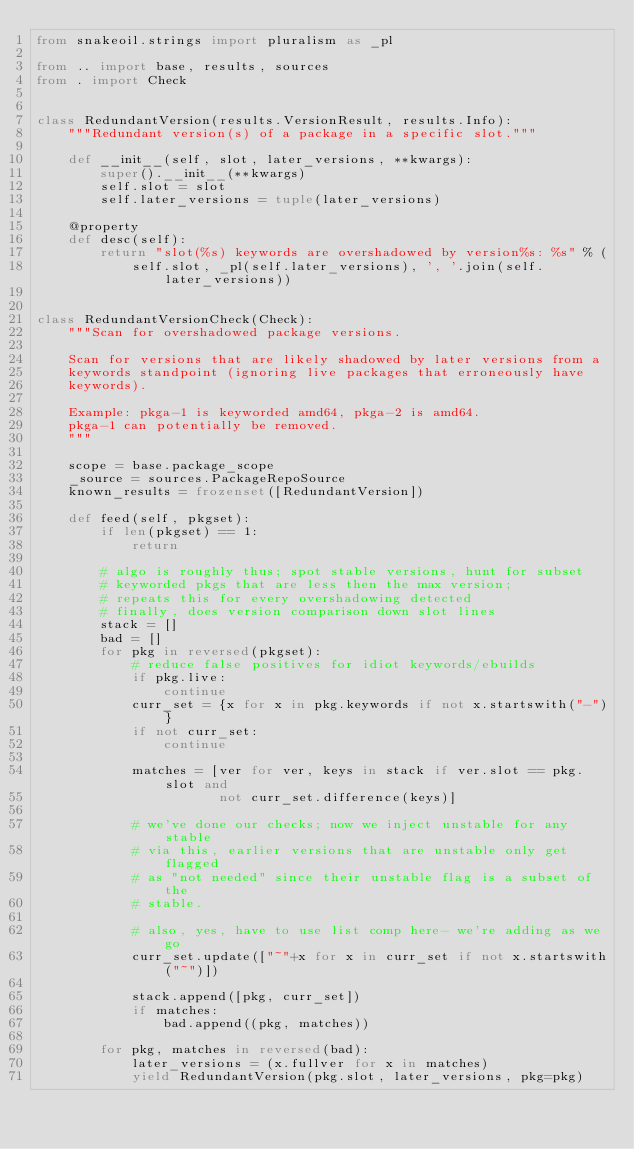<code> <loc_0><loc_0><loc_500><loc_500><_Python_>from snakeoil.strings import pluralism as _pl

from .. import base, results, sources
from . import Check


class RedundantVersion(results.VersionResult, results.Info):
    """Redundant version(s) of a package in a specific slot."""

    def __init__(self, slot, later_versions, **kwargs):
        super().__init__(**kwargs)
        self.slot = slot
        self.later_versions = tuple(later_versions)

    @property
    def desc(self):
        return "slot(%s) keywords are overshadowed by version%s: %s" % (
            self.slot, _pl(self.later_versions), ', '.join(self.later_versions))


class RedundantVersionCheck(Check):
    """Scan for overshadowed package versions.

    Scan for versions that are likely shadowed by later versions from a
    keywords standpoint (ignoring live packages that erroneously have
    keywords).

    Example: pkga-1 is keyworded amd64, pkga-2 is amd64.
    pkga-1 can potentially be removed.
    """

    scope = base.package_scope
    _source = sources.PackageRepoSource
    known_results = frozenset([RedundantVersion])

    def feed(self, pkgset):
        if len(pkgset) == 1:
            return

        # algo is roughly thus; spot stable versions, hunt for subset
        # keyworded pkgs that are less then the max version;
        # repeats this for every overshadowing detected
        # finally, does version comparison down slot lines
        stack = []
        bad = []
        for pkg in reversed(pkgset):
            # reduce false positives for idiot keywords/ebuilds
            if pkg.live:
                continue
            curr_set = {x for x in pkg.keywords if not x.startswith("-")}
            if not curr_set:
                continue

            matches = [ver for ver, keys in stack if ver.slot == pkg.slot and
                       not curr_set.difference(keys)]

            # we've done our checks; now we inject unstable for any stable
            # via this, earlier versions that are unstable only get flagged
            # as "not needed" since their unstable flag is a subset of the
            # stable.

            # also, yes, have to use list comp here- we're adding as we go
            curr_set.update(["~"+x for x in curr_set if not x.startswith("~")])

            stack.append([pkg, curr_set])
            if matches:
                bad.append((pkg, matches))

        for pkg, matches in reversed(bad):
            later_versions = (x.fullver for x in matches)
            yield RedundantVersion(pkg.slot, later_versions, pkg=pkg)
</code> 